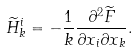<formula> <loc_0><loc_0><loc_500><loc_500>\widetilde { H } _ { k } ^ { i } = - \frac { 1 } { k } \frac { \partial ^ { 2 } { \widetilde { F } } } { \partial { x _ { i } } \partial { x _ { k } } } .</formula> 